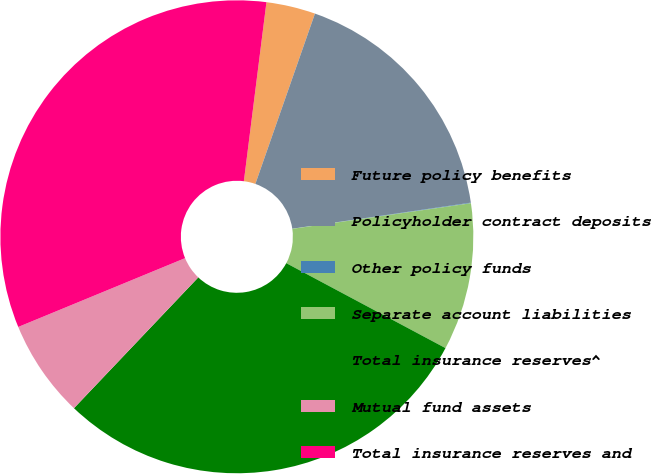Convert chart to OTSL. <chart><loc_0><loc_0><loc_500><loc_500><pie_chart><fcel>Future policy benefits<fcel>Policyholder contract deposits<fcel>Other policy funds<fcel>Separate account liabilities<fcel>Total insurance reserves^<fcel>Mutual fund assets<fcel>Total insurance reserves and<nl><fcel>3.36%<fcel>17.34%<fcel>0.04%<fcel>10.07%<fcel>29.3%<fcel>6.68%<fcel>33.23%<nl></chart> 